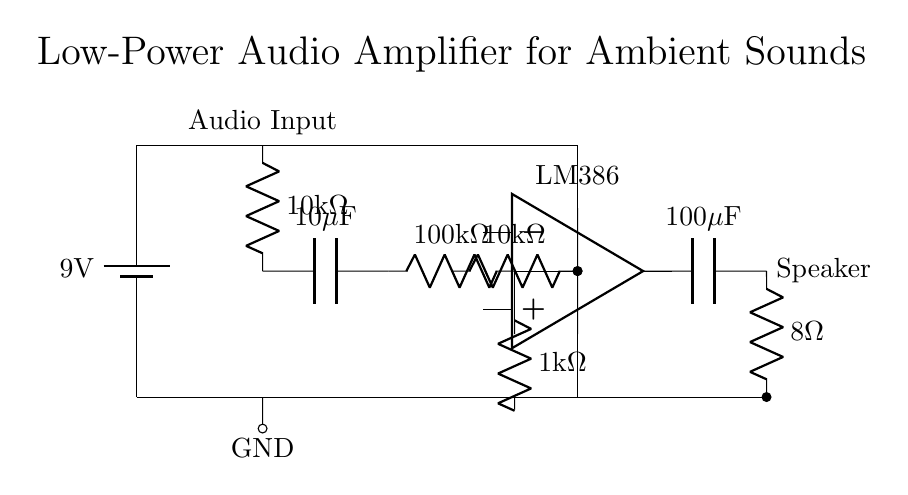What is the voltage of this circuit? The voltage is 9V, which is indicated by the battery symbol labeled with 9 volts at the top of the circuit.
Answer: 9V What type of amplifier is used in this circuit? The amplifier used here is an LM386, which is depicted in the circuit with the op-amp symbol, specifically labeled above it.
Answer: LM386 What is the resistance of the output load? The output load resistance is 8 ohms, as indicated by the resistor symbol connected to the speaker term in the output stage of the circuit.
Answer: 8 ohms How many capacitors are present in the circuit? There are two capacitors in the circuit, specified as 10 microfarads and 100 microfarads, which can be identified by the capacitor symbols in the input and output stages.
Answer: 2 What is the purpose of the 10 kOhm resistor in the input stage? The 10 kOhm resistor serves to limit the input current and can also help set the gain of the circuit. It's located at the beginning of the input stage, connecting the audio input to the subsequent capacitor.
Answer: Limit input current How does the amplifier stage connect to the input stage? The amplifier stage connects to the input stage through a capacitor and a resistor, allowing the audio signal to pass while blocking DC components, which is noted by the connections between the components in the circuit diagram.
Answer: Through a capacitor and resistor What is the function of the 100 microfarad capacitor? The 100 microfarad capacitor acts to couple the AC signal to the load while blocking any DC bias from reaching the speaker, which can be inferred from its position in the output stage connected to the speaker.
Answer: Coupling AC signal 